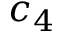Convert formula to latex. <formula><loc_0><loc_0><loc_500><loc_500>c _ { 4 }</formula> 